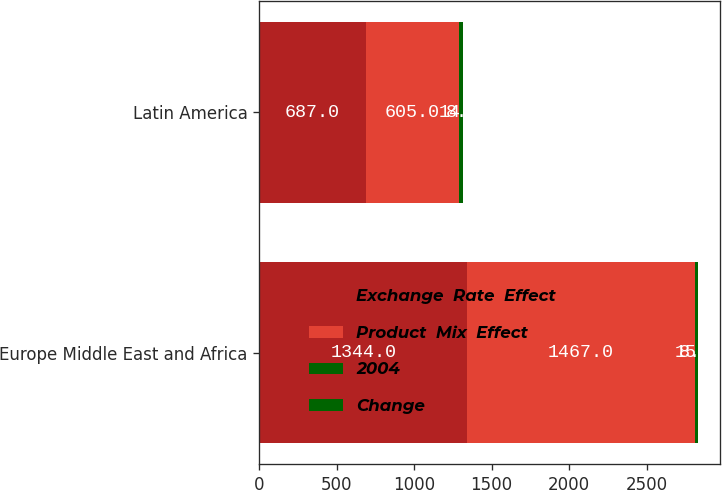Convert chart to OTSL. <chart><loc_0><loc_0><loc_500><loc_500><stacked_bar_chart><ecel><fcel>Europe Middle East and Africa<fcel>Latin America<nl><fcel>Exchange  Rate  Effect<fcel>1344<fcel>687<nl><fcel>Product  Mix  Effect<fcel>1467<fcel>605<nl><fcel>2004<fcel>8<fcel>14<nl><fcel>Change<fcel>15<fcel>8<nl></chart> 